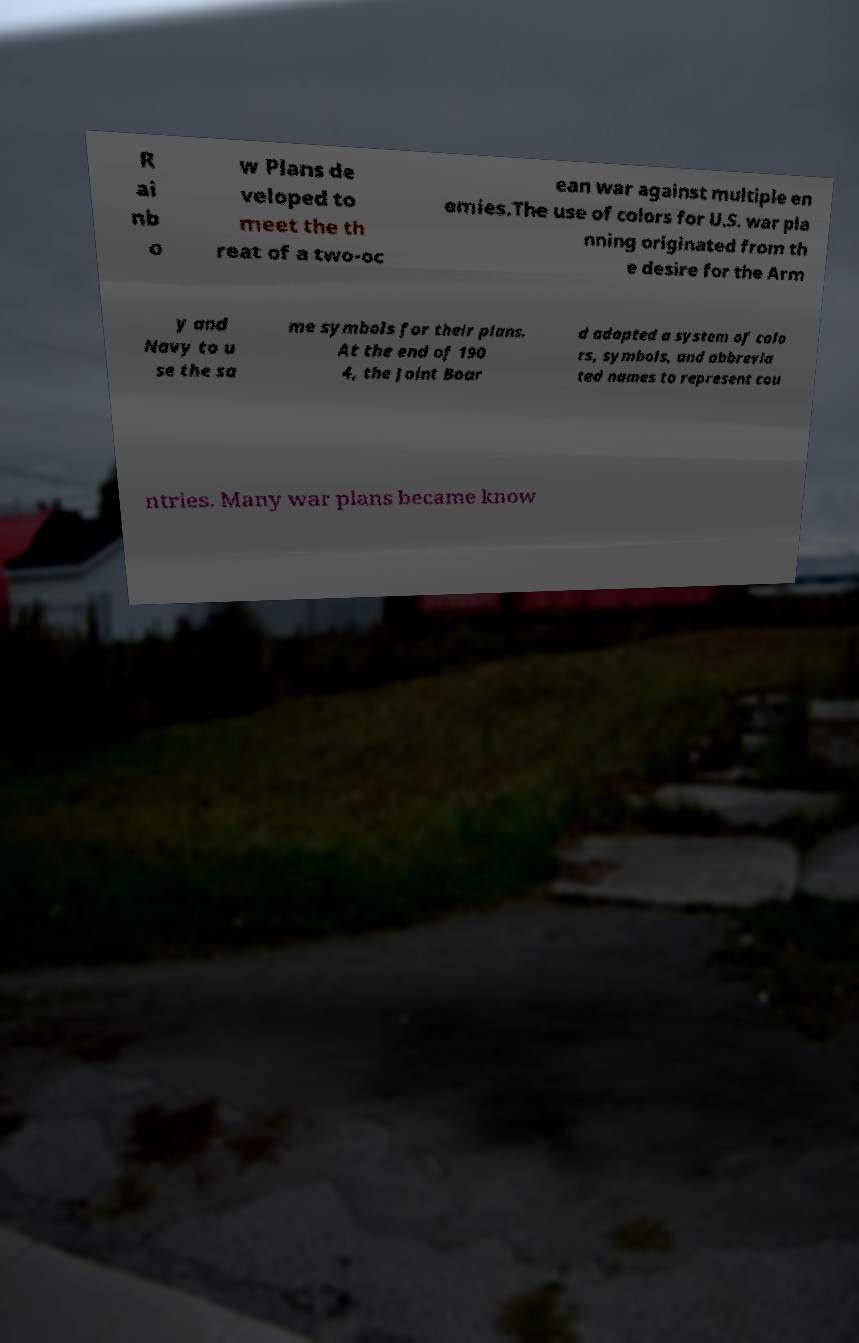There's text embedded in this image that I need extracted. Can you transcribe it verbatim? R ai nb o w Plans de veloped to meet the th reat of a two-oc ean war against multiple en emies.The use of colors for U.S. war pla nning originated from th e desire for the Arm y and Navy to u se the sa me symbols for their plans. At the end of 190 4, the Joint Boar d adopted a system of colo rs, symbols, and abbrevia ted names to represent cou ntries. Many war plans became know 